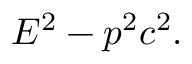Convert formula to latex. <formula><loc_0><loc_0><loc_500><loc_500>E ^ { 2 } - p ^ { 2 } c ^ { 2 } .</formula> 